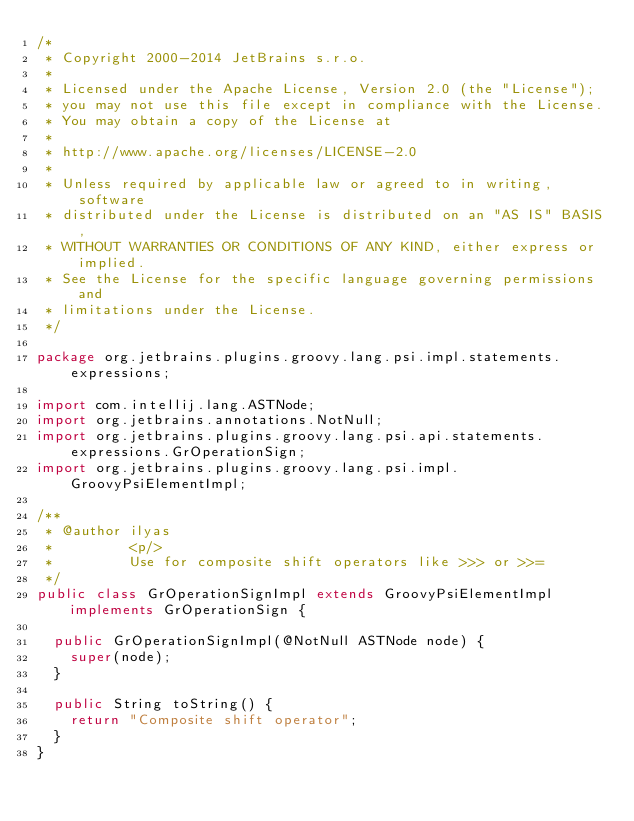Convert code to text. <code><loc_0><loc_0><loc_500><loc_500><_Java_>/*
 * Copyright 2000-2014 JetBrains s.r.o.
 *
 * Licensed under the Apache License, Version 2.0 (the "License");
 * you may not use this file except in compliance with the License.
 * You may obtain a copy of the License at
 *
 * http://www.apache.org/licenses/LICENSE-2.0
 *
 * Unless required by applicable law or agreed to in writing, software
 * distributed under the License is distributed on an "AS IS" BASIS,
 * WITHOUT WARRANTIES OR CONDITIONS OF ANY KIND, either express or implied.
 * See the License for the specific language governing permissions and
 * limitations under the License.
 */

package org.jetbrains.plugins.groovy.lang.psi.impl.statements.expressions;

import com.intellij.lang.ASTNode;
import org.jetbrains.annotations.NotNull;
import org.jetbrains.plugins.groovy.lang.psi.api.statements.expressions.GrOperationSign;
import org.jetbrains.plugins.groovy.lang.psi.impl.GroovyPsiElementImpl;

/**
 * @author ilyas
 *         <p/>
 *         Use for composite shift operators like >>> or >>=
 */
public class GrOperationSignImpl extends GroovyPsiElementImpl implements GrOperationSign {

  public GrOperationSignImpl(@NotNull ASTNode node) {
    super(node);
  }

  public String toString() {
    return "Composite shift operator";
  }
}
</code> 